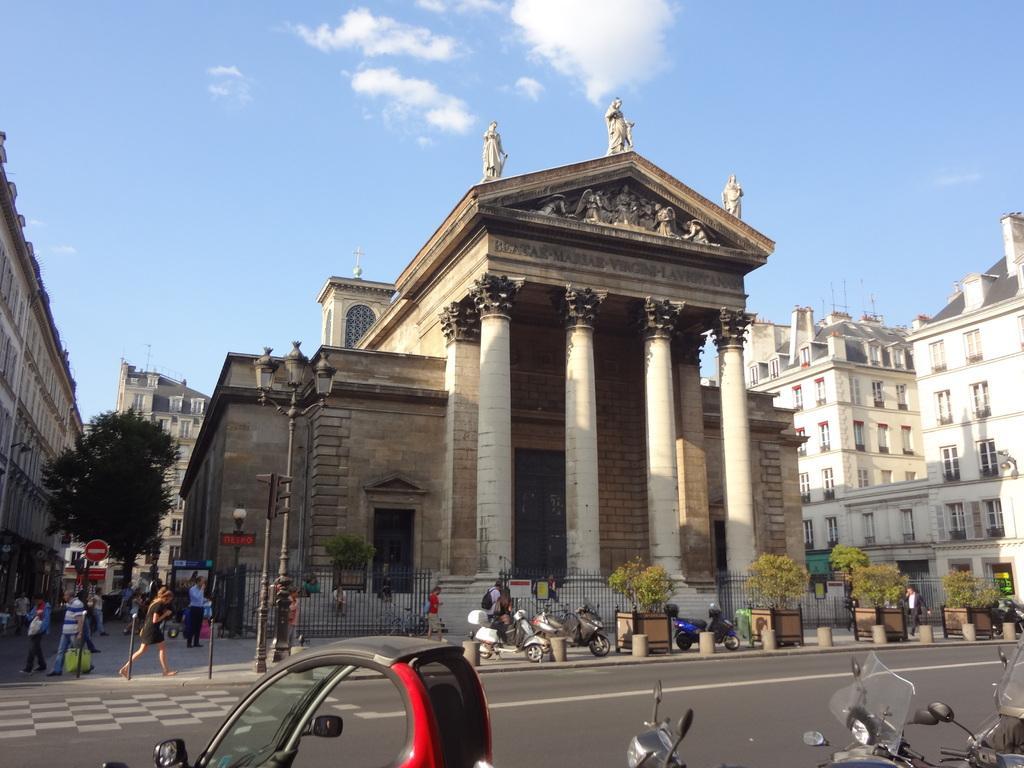Can you describe this image briefly? In the foreground of the image we can see group of vehicles parked on the road. In the center of the image we can see a building with doors, poles and statues. On the left side of the image we can see a group of people standing on the path a tree, two buildings, traffic lights, sign boards. To the right side of the image we can see trees and a cloudy sky. 